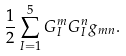Convert formula to latex. <formula><loc_0><loc_0><loc_500><loc_500>\frac { 1 } { 2 } \sum _ { I = 1 } ^ { 5 } G _ { I } ^ { m } G _ { I } ^ { n } g _ { m n } .</formula> 